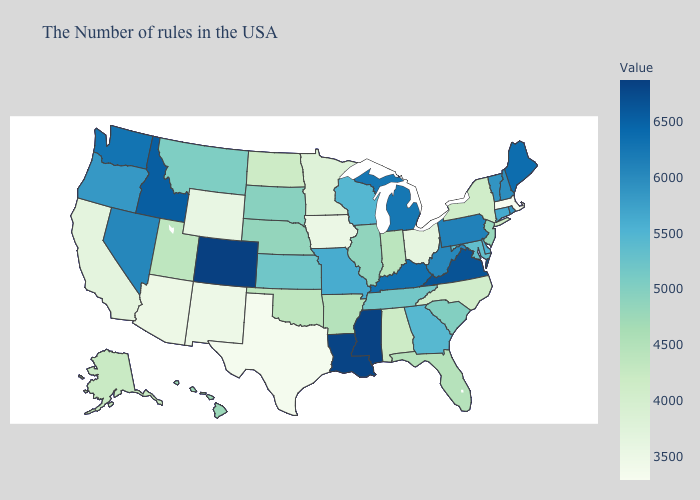Does Texas have the lowest value in the South?
Be succinct. Yes. Does Kansas have a higher value than Washington?
Give a very brief answer. No. Among the states that border New Mexico , which have the lowest value?
Give a very brief answer. Texas. Which states have the lowest value in the USA?
Answer briefly. Massachusetts. Does Missouri have the lowest value in the USA?
Answer briefly. No. Among the states that border Missouri , which have the lowest value?
Keep it brief. Iowa. 